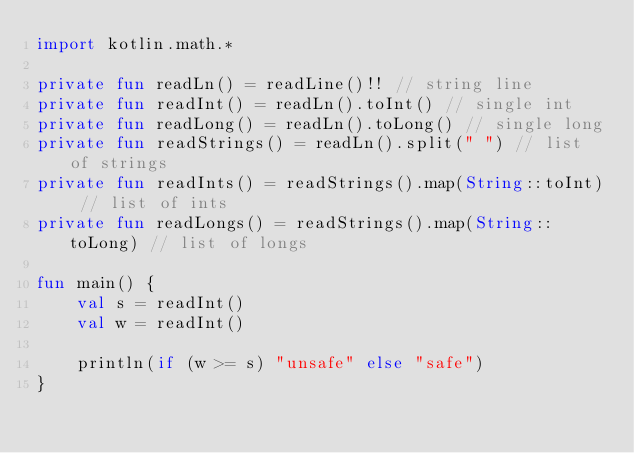Convert code to text. <code><loc_0><loc_0><loc_500><loc_500><_Kotlin_>import kotlin.math.*

private fun readLn() = readLine()!! // string line
private fun readInt() = readLn().toInt() // single int
private fun readLong() = readLn().toLong() // single long
private fun readStrings() = readLn().split(" ") // list of strings
private fun readInts() = readStrings().map(String::toInt) // list of ints
private fun readLongs() = readStrings().map(String::toLong) // list of longs

fun main() {
    val s = readInt()
    val w = readInt()

    println(if (w >= s) "unsafe" else "safe")
}


</code> 